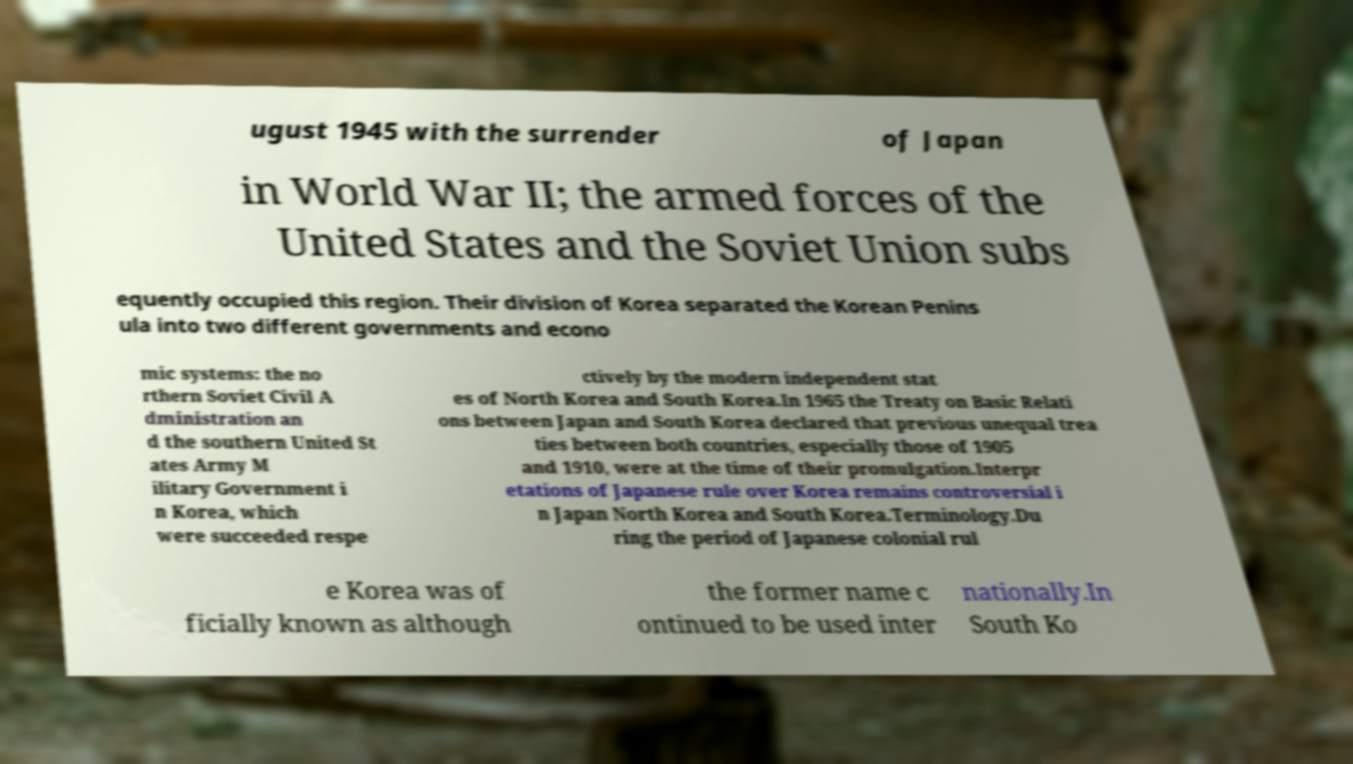Can you read and provide the text displayed in the image?This photo seems to have some interesting text. Can you extract and type it out for me? ugust 1945 with the surrender of Japan in World War II; the armed forces of the United States and the Soviet Union subs equently occupied this region. Their division of Korea separated the Korean Penins ula into two different governments and econo mic systems: the no rthern Soviet Civil A dministration an d the southern United St ates Army M ilitary Government i n Korea, which were succeeded respe ctively by the modern independent stat es of North Korea and South Korea.In 1965 the Treaty on Basic Relati ons between Japan and South Korea declared that previous unequal trea ties between both countries, especially those of 1905 and 1910, were at the time of their promulgation.Interpr etations of Japanese rule over Korea remains controversial i n Japan North Korea and South Korea.Terminology.Du ring the period of Japanese colonial rul e Korea was of ficially known as although the former name c ontinued to be used inter nationally.In South Ko 